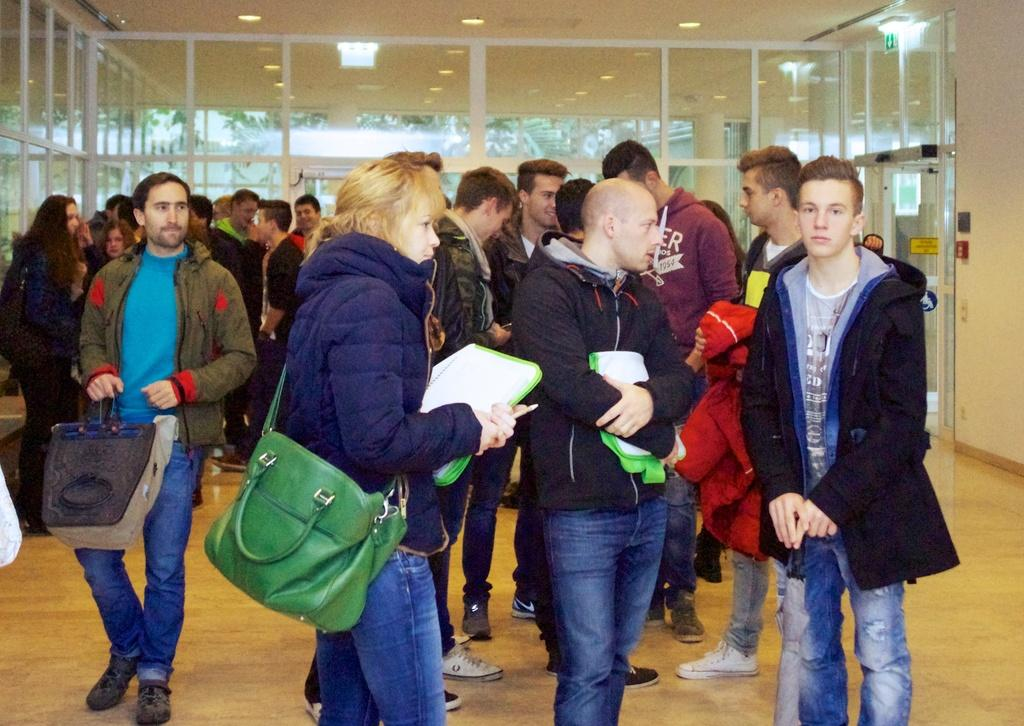How many people are in the image? There is a group of people standing in the image, but the exact number is not specified. Where are the people standing in the image? The people are standing on the floor. What can be seen in the background of the image? There is a door visible in the background of the image. What is visible at the top of the image? There are lights visible at the top of the image. What type of sugar is being used in the school joke depicted in the image? There is no sugar, school, or joke present in the image. 